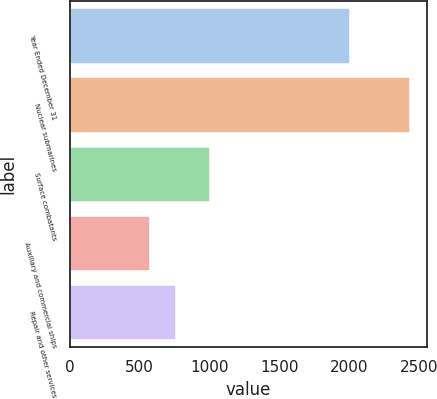Convert chart to OTSL. <chart><loc_0><loc_0><loc_500><loc_500><bar_chart><fcel>Year Ended December 31<fcel>Nuclear submarines<fcel>Surface combatants<fcel>Auxiliary and commercial ships<fcel>Repair and other services<nl><fcel>2004<fcel>2432<fcel>1002<fcel>576<fcel>761.6<nl></chart> 